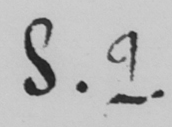What does this handwritten line say? S . 2 . 